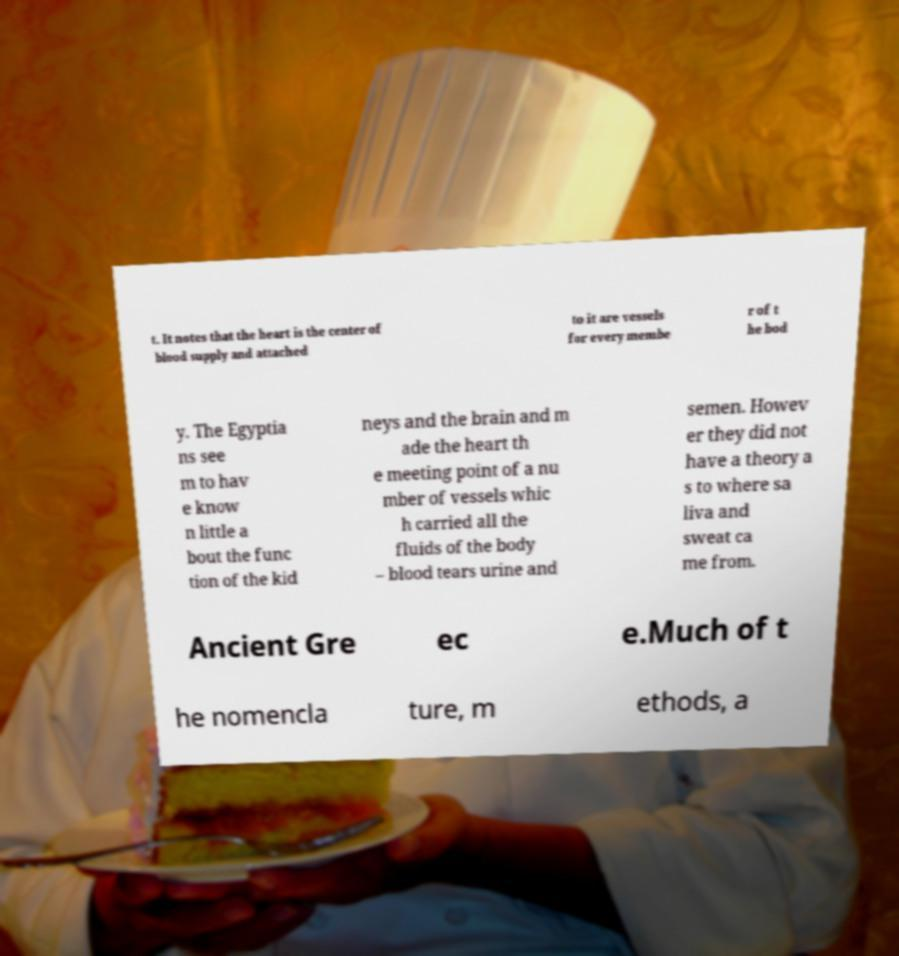Could you extract and type out the text from this image? t. It notes that the heart is the center of blood supply and attached to it are vessels for every membe r of t he bod y. The Egyptia ns see m to hav e know n little a bout the func tion of the kid neys and the brain and m ade the heart th e meeting point of a nu mber of vessels whic h carried all the fluids of the body – blood tears urine and semen. Howev er they did not have a theory a s to where sa liva and sweat ca me from. Ancient Gre ec e.Much of t he nomencla ture, m ethods, a 